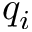Convert formula to latex. <formula><loc_0><loc_0><loc_500><loc_500>q _ { i }</formula> 